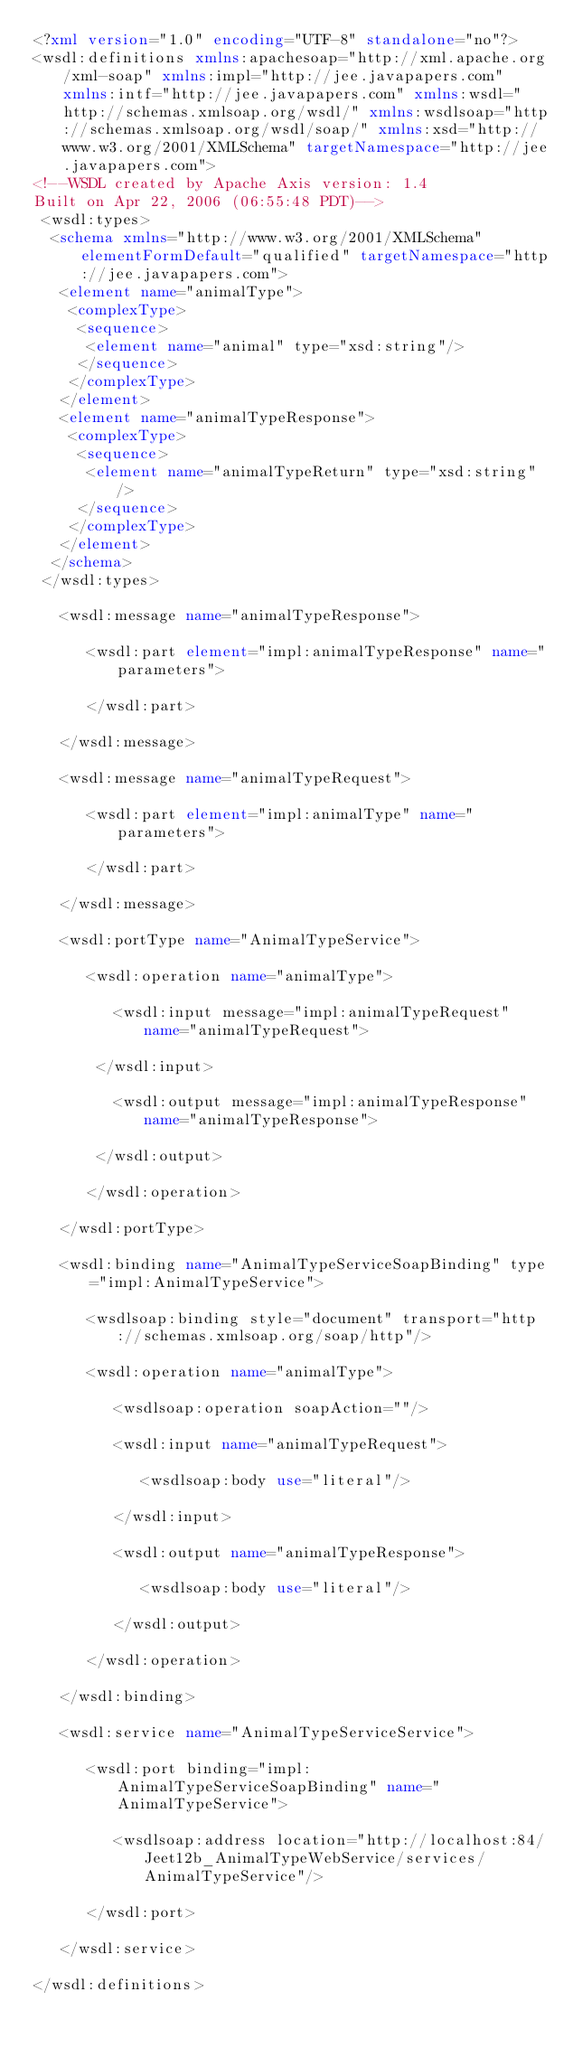<code> <loc_0><loc_0><loc_500><loc_500><_XML_><?xml version="1.0" encoding="UTF-8" standalone="no"?>
<wsdl:definitions xmlns:apachesoap="http://xml.apache.org/xml-soap" xmlns:impl="http://jee.javapapers.com" xmlns:intf="http://jee.javapapers.com" xmlns:wsdl="http://schemas.xmlsoap.org/wsdl/" xmlns:wsdlsoap="http://schemas.xmlsoap.org/wsdl/soap/" xmlns:xsd="http://www.w3.org/2001/XMLSchema" targetNamespace="http://jee.javapapers.com">
<!--WSDL created by Apache Axis version: 1.4
Built on Apr 22, 2006 (06:55:48 PDT)-->
 <wsdl:types>
  <schema xmlns="http://www.w3.org/2001/XMLSchema" elementFormDefault="qualified" targetNamespace="http://jee.javapapers.com">
   <element name="animalType">
    <complexType>
     <sequence>
      <element name="animal" type="xsd:string"/>
     </sequence>
    </complexType>
   </element>
   <element name="animalTypeResponse">
    <complexType>
     <sequence>
      <element name="animalTypeReturn" type="xsd:string"/>
     </sequence>
    </complexType>
   </element>
  </schema>
 </wsdl:types>

   <wsdl:message name="animalTypeResponse">

      <wsdl:part element="impl:animalTypeResponse" name="parameters">

      </wsdl:part>

   </wsdl:message>

   <wsdl:message name="animalTypeRequest">

      <wsdl:part element="impl:animalType" name="parameters">

      </wsdl:part>

   </wsdl:message>

   <wsdl:portType name="AnimalTypeService">

      <wsdl:operation name="animalType">

         <wsdl:input message="impl:animalTypeRequest" name="animalTypeRequest">

       </wsdl:input>

         <wsdl:output message="impl:animalTypeResponse" name="animalTypeResponse">

       </wsdl:output>

      </wsdl:operation>

   </wsdl:portType>

   <wsdl:binding name="AnimalTypeServiceSoapBinding" type="impl:AnimalTypeService">

      <wsdlsoap:binding style="document" transport="http://schemas.xmlsoap.org/soap/http"/>

      <wsdl:operation name="animalType">

         <wsdlsoap:operation soapAction=""/>

         <wsdl:input name="animalTypeRequest">

            <wsdlsoap:body use="literal"/>

         </wsdl:input>

         <wsdl:output name="animalTypeResponse">

            <wsdlsoap:body use="literal"/>

         </wsdl:output>

      </wsdl:operation>

   </wsdl:binding>

   <wsdl:service name="AnimalTypeServiceService">

      <wsdl:port binding="impl:AnimalTypeServiceSoapBinding" name="AnimalTypeService">

         <wsdlsoap:address location="http://localhost:84/Jeet12b_AnimalTypeWebService/services/AnimalTypeService"/>

      </wsdl:port>

   </wsdl:service>

</wsdl:definitions>
</code> 